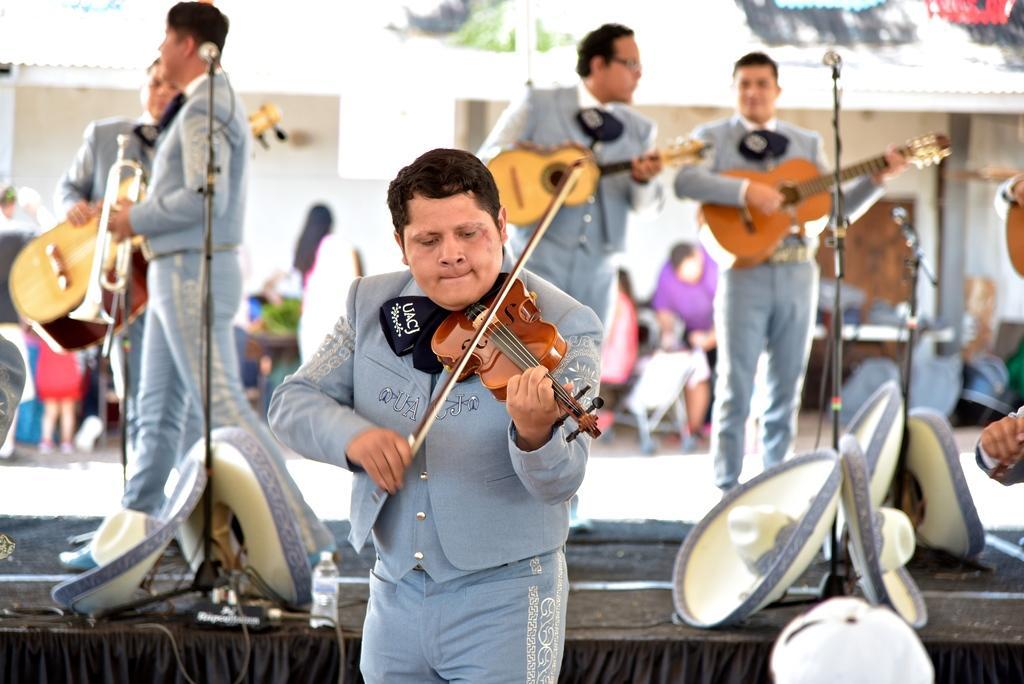Describe this image in one or two sentences. In the center of the picture a man is standing and playing. On the right a man is standing and playing guitar. In the background in the center a person is standing and playing guitar. On the left a person is standing and playing trampoline, behind him there is person standing and playing musical instrument. In the background there is a wall, in front of the wall there are people standing. In the foreground there is a stage, on the stage there are hats, microphones and water bottle. 